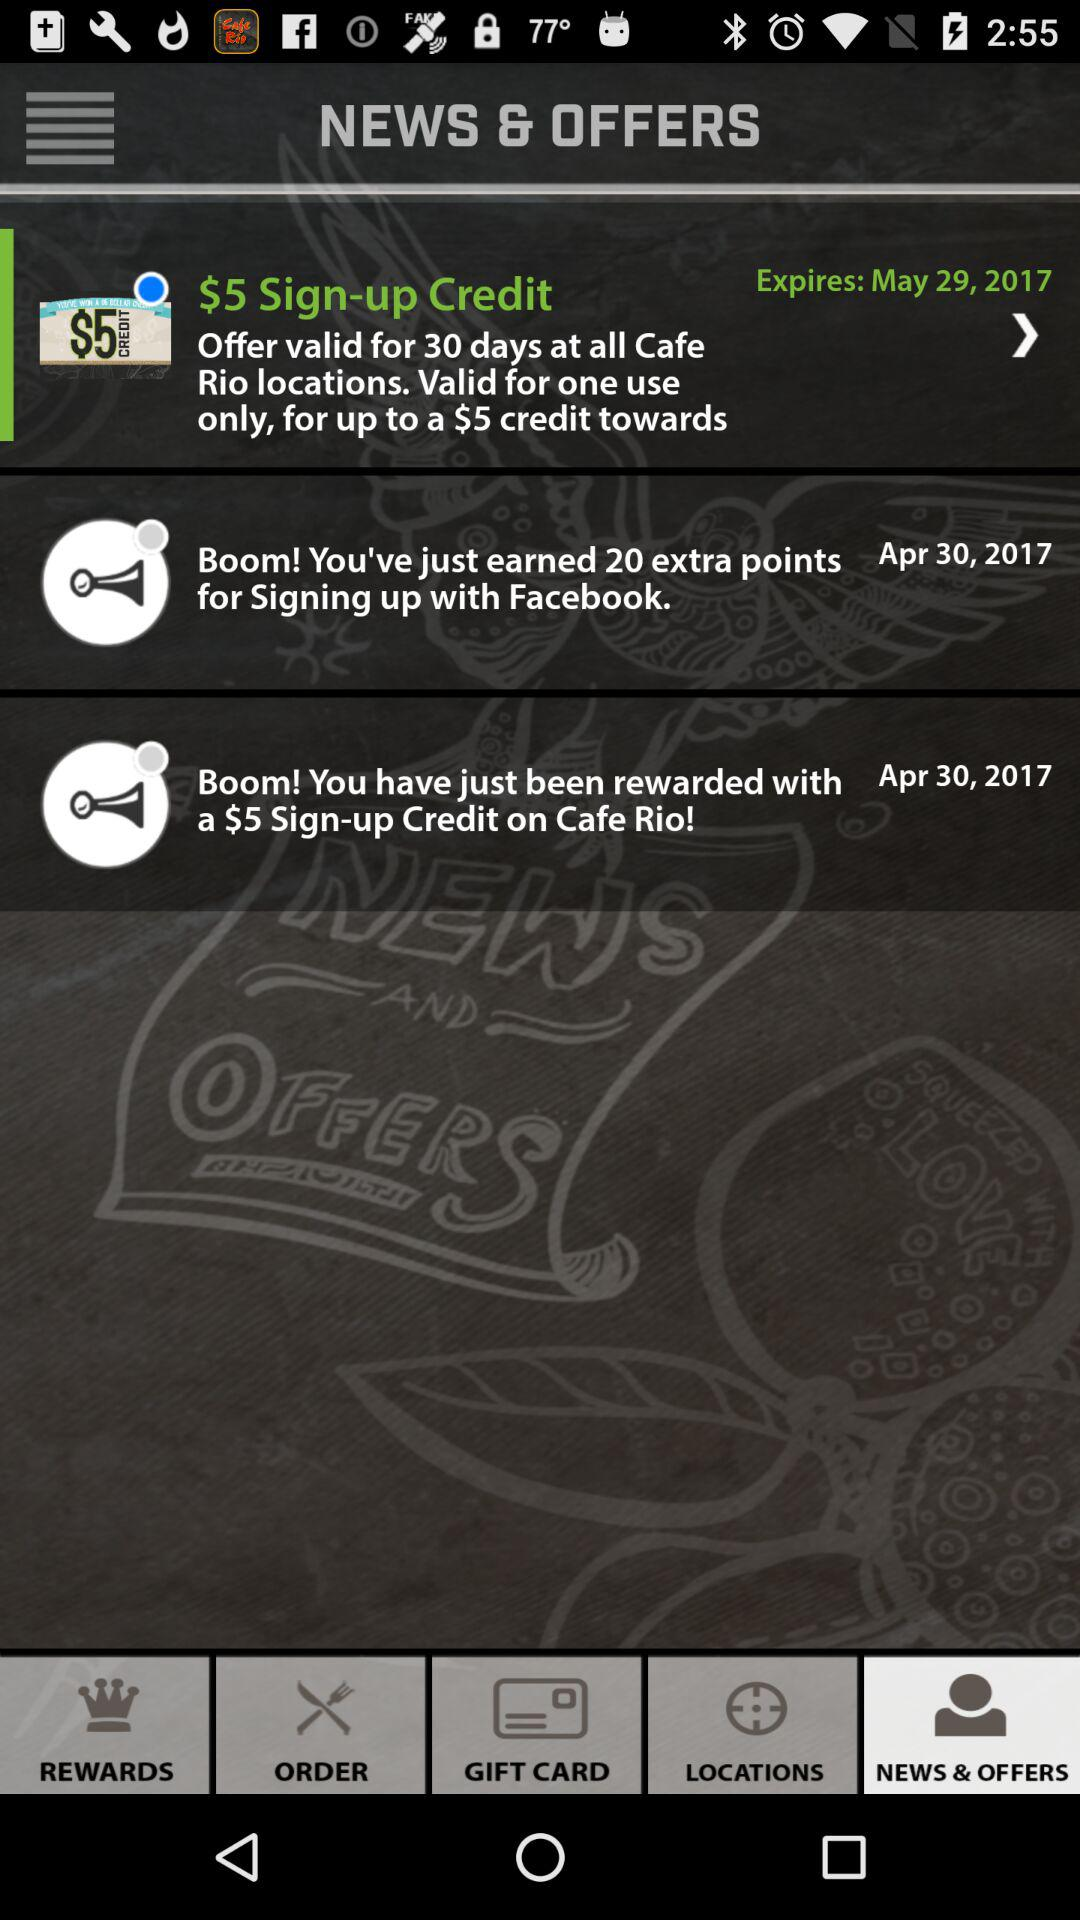Which option in the bottom bar has been selected? The option that has been selected is "News & offers". 